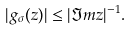Convert formula to latex. <formula><loc_0><loc_0><loc_500><loc_500>| g _ { \sigma } ( z ) | \leq | \Im m z | ^ { - 1 } .</formula> 